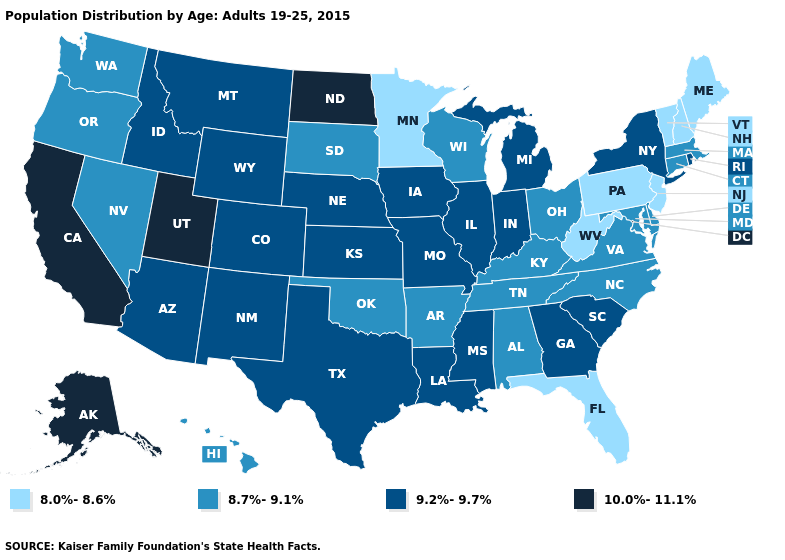Does Mississippi have the same value as Missouri?
Be succinct. Yes. Does Oregon have the lowest value in the West?
Answer briefly. Yes. What is the value of Kentucky?
Give a very brief answer. 8.7%-9.1%. Name the states that have a value in the range 10.0%-11.1%?
Write a very short answer. Alaska, California, North Dakota, Utah. Among the states that border Kansas , does Oklahoma have the highest value?
Short answer required. No. Does South Carolina have the lowest value in the USA?
Write a very short answer. No. Which states have the lowest value in the Northeast?
Concise answer only. Maine, New Hampshire, New Jersey, Pennsylvania, Vermont. Name the states that have a value in the range 8.0%-8.6%?
Write a very short answer. Florida, Maine, Minnesota, New Hampshire, New Jersey, Pennsylvania, Vermont, West Virginia. What is the lowest value in states that border Maine?
Write a very short answer. 8.0%-8.6%. What is the lowest value in states that border Pennsylvania?
Quick response, please. 8.0%-8.6%. What is the value of Hawaii?
Short answer required. 8.7%-9.1%. What is the value of Oregon?
Be succinct. 8.7%-9.1%. Name the states that have a value in the range 8.7%-9.1%?
Answer briefly. Alabama, Arkansas, Connecticut, Delaware, Hawaii, Kentucky, Maryland, Massachusetts, Nevada, North Carolina, Ohio, Oklahoma, Oregon, South Dakota, Tennessee, Virginia, Washington, Wisconsin. 